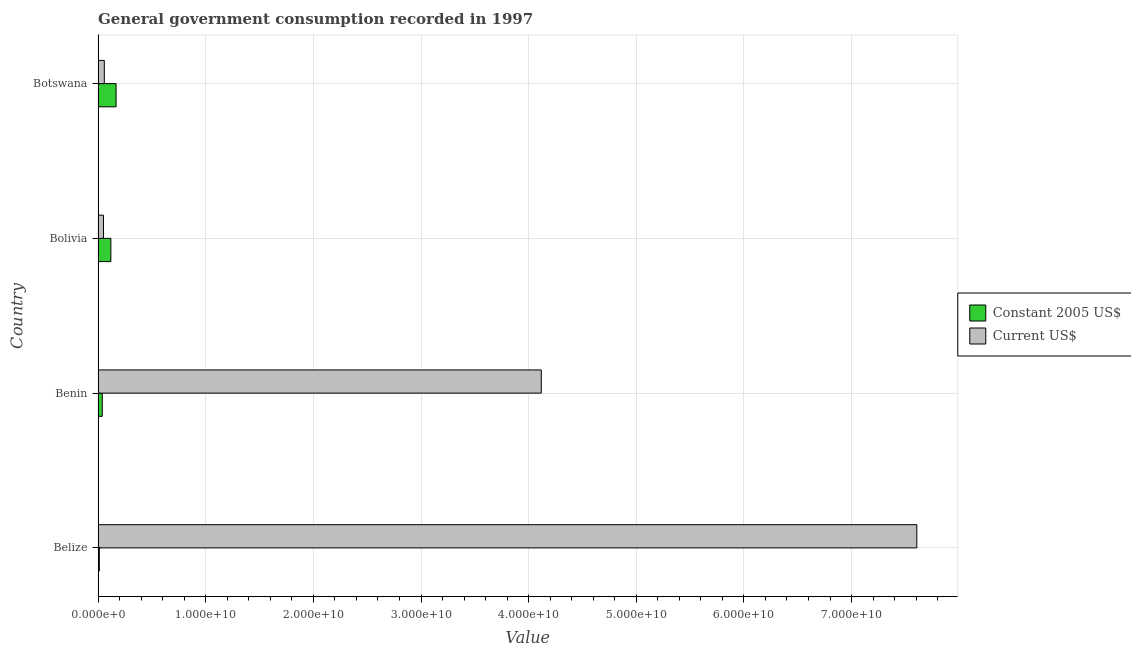How many different coloured bars are there?
Keep it short and to the point. 2. How many groups of bars are there?
Your response must be concise. 4. Are the number of bars per tick equal to the number of legend labels?
Keep it short and to the point. Yes. Are the number of bars on each tick of the Y-axis equal?
Your answer should be very brief. Yes. How many bars are there on the 2nd tick from the top?
Offer a terse response. 2. What is the label of the 4th group of bars from the top?
Your response must be concise. Belize. What is the value consumed in current us$ in Belize?
Your answer should be compact. 7.61e+1. Across all countries, what is the maximum value consumed in constant 2005 us$?
Offer a very short reply. 1.67e+09. Across all countries, what is the minimum value consumed in constant 2005 us$?
Your answer should be very brief. 1.16e+08. In which country was the value consumed in current us$ maximum?
Provide a succinct answer. Belize. What is the total value consumed in constant 2005 us$ in the graph?
Make the answer very short. 3.36e+09. What is the difference between the value consumed in current us$ in Benin and that in Botswana?
Your answer should be compact. 4.06e+1. What is the difference between the value consumed in constant 2005 us$ in Botswana and the value consumed in current us$ in Belize?
Provide a succinct answer. -7.44e+1. What is the average value consumed in constant 2005 us$ per country?
Provide a short and direct response. 8.41e+08. What is the difference between the value consumed in current us$ and value consumed in constant 2005 us$ in Belize?
Your answer should be very brief. 7.59e+1. In how many countries, is the value consumed in constant 2005 us$ greater than 8000000000 ?
Offer a terse response. 0. What is the ratio of the value consumed in constant 2005 us$ in Benin to that in Botswana?
Provide a short and direct response. 0.23. Is the difference between the value consumed in current us$ in Bolivia and Botswana greater than the difference between the value consumed in constant 2005 us$ in Bolivia and Botswana?
Ensure brevity in your answer.  Yes. What is the difference between the highest and the second highest value consumed in constant 2005 us$?
Offer a very short reply. 4.84e+08. What is the difference between the highest and the lowest value consumed in constant 2005 us$?
Keep it short and to the point. 1.56e+09. In how many countries, is the value consumed in current us$ greater than the average value consumed in current us$ taken over all countries?
Offer a terse response. 2. Is the sum of the value consumed in current us$ in Belize and Botswana greater than the maximum value consumed in constant 2005 us$ across all countries?
Make the answer very short. Yes. What does the 1st bar from the top in Benin represents?
Give a very brief answer. Current US$. What does the 1st bar from the bottom in Benin represents?
Provide a succinct answer. Constant 2005 US$. How many bars are there?
Offer a very short reply. 8. Are the values on the major ticks of X-axis written in scientific E-notation?
Offer a terse response. Yes. Does the graph contain any zero values?
Give a very brief answer. No. Does the graph contain grids?
Your answer should be very brief. Yes. How many legend labels are there?
Offer a terse response. 2. How are the legend labels stacked?
Give a very brief answer. Vertical. What is the title of the graph?
Provide a succinct answer. General government consumption recorded in 1997. What is the label or title of the X-axis?
Your answer should be compact. Value. What is the label or title of the Y-axis?
Give a very brief answer. Country. What is the Value of Constant 2005 US$ in Belize?
Provide a short and direct response. 1.16e+08. What is the Value in Current US$ in Belize?
Provide a succinct answer. 7.61e+1. What is the Value of Constant 2005 US$ in Benin?
Give a very brief answer. 3.89e+08. What is the Value of Current US$ in Benin?
Keep it short and to the point. 4.12e+1. What is the Value in Constant 2005 US$ in Bolivia?
Your answer should be very brief. 1.19e+09. What is the Value in Current US$ in Bolivia?
Give a very brief answer. 5.00e+08. What is the Value of Constant 2005 US$ in Botswana?
Give a very brief answer. 1.67e+09. What is the Value of Current US$ in Botswana?
Provide a short and direct response. 5.78e+08. Across all countries, what is the maximum Value of Constant 2005 US$?
Give a very brief answer. 1.67e+09. Across all countries, what is the maximum Value of Current US$?
Offer a terse response. 7.61e+1. Across all countries, what is the minimum Value of Constant 2005 US$?
Ensure brevity in your answer.  1.16e+08. Across all countries, what is the minimum Value in Current US$?
Ensure brevity in your answer.  5.00e+08. What is the total Value of Constant 2005 US$ in the graph?
Your answer should be compact. 3.36e+09. What is the total Value in Current US$ in the graph?
Provide a short and direct response. 1.18e+11. What is the difference between the Value of Constant 2005 US$ in Belize and that in Benin?
Offer a terse response. -2.73e+08. What is the difference between the Value of Current US$ in Belize and that in Benin?
Your response must be concise. 3.49e+1. What is the difference between the Value in Constant 2005 US$ in Belize and that in Bolivia?
Keep it short and to the point. -1.07e+09. What is the difference between the Value of Current US$ in Belize and that in Bolivia?
Provide a short and direct response. 7.56e+1. What is the difference between the Value of Constant 2005 US$ in Belize and that in Botswana?
Your answer should be compact. -1.56e+09. What is the difference between the Value of Current US$ in Belize and that in Botswana?
Your answer should be compact. 7.55e+1. What is the difference between the Value in Constant 2005 US$ in Benin and that in Bolivia?
Make the answer very short. -7.98e+08. What is the difference between the Value of Current US$ in Benin and that in Bolivia?
Keep it short and to the point. 4.07e+1. What is the difference between the Value of Constant 2005 US$ in Benin and that in Botswana?
Your answer should be very brief. -1.28e+09. What is the difference between the Value in Current US$ in Benin and that in Botswana?
Offer a terse response. 4.06e+1. What is the difference between the Value in Constant 2005 US$ in Bolivia and that in Botswana?
Offer a very short reply. -4.84e+08. What is the difference between the Value in Current US$ in Bolivia and that in Botswana?
Offer a terse response. -7.87e+07. What is the difference between the Value of Constant 2005 US$ in Belize and the Value of Current US$ in Benin?
Your response must be concise. -4.11e+1. What is the difference between the Value of Constant 2005 US$ in Belize and the Value of Current US$ in Bolivia?
Your answer should be compact. -3.84e+08. What is the difference between the Value of Constant 2005 US$ in Belize and the Value of Current US$ in Botswana?
Keep it short and to the point. -4.63e+08. What is the difference between the Value of Constant 2005 US$ in Benin and the Value of Current US$ in Bolivia?
Provide a short and direct response. -1.11e+08. What is the difference between the Value in Constant 2005 US$ in Benin and the Value in Current US$ in Botswana?
Your response must be concise. -1.89e+08. What is the difference between the Value in Constant 2005 US$ in Bolivia and the Value in Current US$ in Botswana?
Offer a very short reply. 6.09e+08. What is the average Value in Constant 2005 US$ per country?
Offer a terse response. 8.41e+08. What is the average Value in Current US$ per country?
Keep it short and to the point. 2.96e+1. What is the difference between the Value in Constant 2005 US$ and Value in Current US$ in Belize?
Your answer should be compact. -7.59e+1. What is the difference between the Value of Constant 2005 US$ and Value of Current US$ in Benin?
Keep it short and to the point. -4.08e+1. What is the difference between the Value of Constant 2005 US$ and Value of Current US$ in Bolivia?
Offer a very short reply. 6.87e+08. What is the difference between the Value in Constant 2005 US$ and Value in Current US$ in Botswana?
Provide a succinct answer. 1.09e+09. What is the ratio of the Value in Constant 2005 US$ in Belize to that in Benin?
Provide a succinct answer. 0.3. What is the ratio of the Value of Current US$ in Belize to that in Benin?
Offer a very short reply. 1.85. What is the ratio of the Value in Constant 2005 US$ in Belize to that in Bolivia?
Provide a short and direct response. 0.1. What is the ratio of the Value in Current US$ in Belize to that in Bolivia?
Offer a very short reply. 152.19. What is the ratio of the Value of Constant 2005 US$ in Belize to that in Botswana?
Your answer should be very brief. 0.07. What is the ratio of the Value of Current US$ in Belize to that in Botswana?
Offer a very short reply. 131.49. What is the ratio of the Value in Constant 2005 US$ in Benin to that in Bolivia?
Provide a succinct answer. 0.33. What is the ratio of the Value of Current US$ in Benin to that in Bolivia?
Your answer should be compact. 82.39. What is the ratio of the Value of Constant 2005 US$ in Benin to that in Botswana?
Offer a terse response. 0.23. What is the ratio of the Value of Current US$ in Benin to that in Botswana?
Keep it short and to the point. 71.18. What is the ratio of the Value in Constant 2005 US$ in Bolivia to that in Botswana?
Your answer should be compact. 0.71. What is the ratio of the Value in Current US$ in Bolivia to that in Botswana?
Provide a short and direct response. 0.86. What is the difference between the highest and the second highest Value of Constant 2005 US$?
Give a very brief answer. 4.84e+08. What is the difference between the highest and the second highest Value of Current US$?
Your response must be concise. 3.49e+1. What is the difference between the highest and the lowest Value of Constant 2005 US$?
Provide a succinct answer. 1.56e+09. What is the difference between the highest and the lowest Value in Current US$?
Provide a succinct answer. 7.56e+1. 